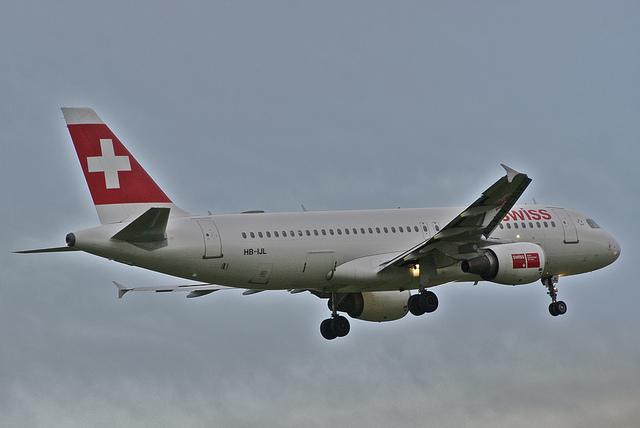Is this plane in the air?
Concise answer only. Yes. Is this a Russian plane?
Concise answer only. No. Is this airplane on the runway or is it flying?
Short answer required. Flying. Is the plane landing?
Concise answer only. Yes. What is the image on the plane's tail?
Concise answer only. Cross. What is on the plains tail?
Give a very brief answer. Cross. 